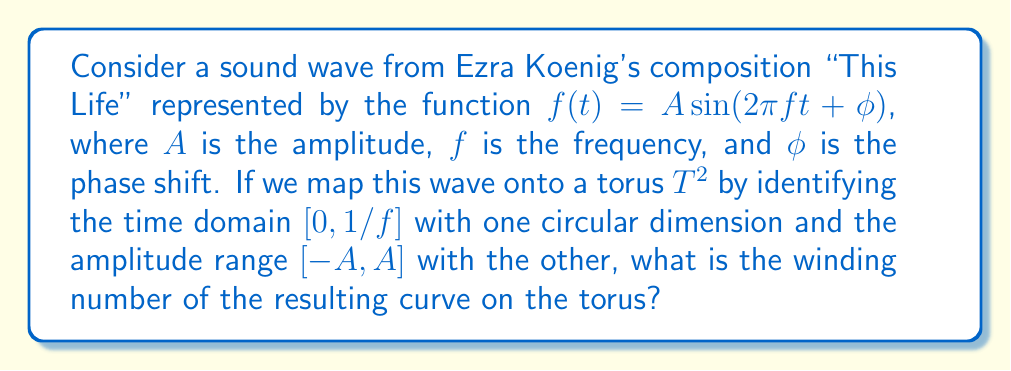What is the answer to this math problem? To solve this problem, we need to understand the topological mapping of the sound wave onto a torus and analyze its winding behavior:

1) First, we map the time domain $[0, 1/f]$ to the longitude of the torus, making a complete revolution.

2) The amplitude range $[-A, A]$ is mapped to the latitude of the torus.

3) The sine function completes one full cycle in the interval $[0, 1/f]$, as $2\pi f \cdot (1/f) = 2\pi$.

4) On the torus, this means the curve makes one complete revolution around the "tube" of the torus in the longitudinal direction.

5) In the latitudinal direction, the curve goes from $0$ to $A$ to $-A$ and back to $0$ exactly once during this revolution.

6) The winding number in topology refers to the number of times a curve travels around a point or surface in a 2D plane or higher-dimensional space.

7) In this case, we're interested in how many times the curve winds around the "hole" of the torus.

8) Since the curve makes one complete revolution longitudinally and one complete oscillation latitudinally, it winds around the hole of the torus exactly once.

Therefore, the winding number of the curve on the torus is 1.
Answer: The winding number of the sound wave curve on the torus is 1. 